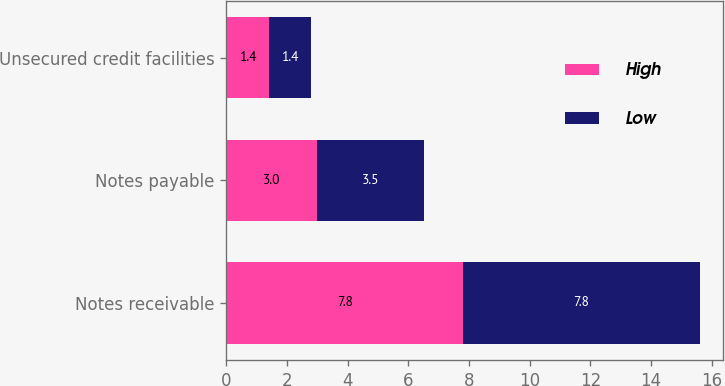<chart> <loc_0><loc_0><loc_500><loc_500><stacked_bar_chart><ecel><fcel>Notes receivable<fcel>Notes payable<fcel>Unsecured credit facilities<nl><fcel>High<fcel>7.8<fcel>3<fcel>1.4<nl><fcel>Low<fcel>7.8<fcel>3.5<fcel>1.4<nl></chart> 